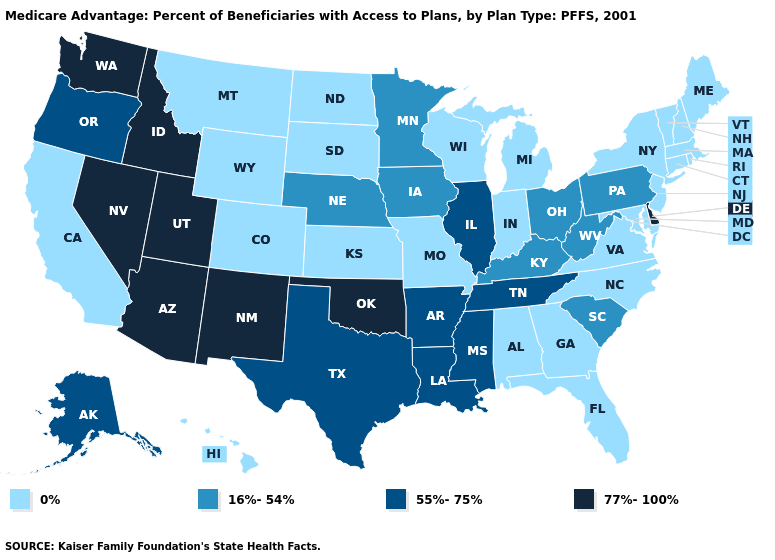Does Pennsylvania have the lowest value in the Northeast?
Answer briefly. No. Name the states that have a value in the range 55%-75%?
Give a very brief answer. Alaska, Arkansas, Illinois, Louisiana, Mississippi, Oregon, Tennessee, Texas. What is the value of Iowa?
Give a very brief answer. 16%-54%. What is the value of Pennsylvania?
Write a very short answer. 16%-54%. Does Nevada have a lower value than Massachusetts?
Concise answer only. No. Name the states that have a value in the range 0%?
Write a very short answer. Alabama, California, Colorado, Connecticut, Florida, Georgia, Hawaii, Indiana, Kansas, Massachusetts, Maryland, Maine, Michigan, Missouri, Montana, North Carolina, North Dakota, New Hampshire, New Jersey, New York, Rhode Island, South Dakota, Virginia, Vermont, Wisconsin, Wyoming. What is the value of Texas?
Be succinct. 55%-75%. Does Idaho have the highest value in the West?
Concise answer only. Yes. What is the value of New York?
Short answer required. 0%. Name the states that have a value in the range 0%?
Short answer required. Alabama, California, Colorado, Connecticut, Florida, Georgia, Hawaii, Indiana, Kansas, Massachusetts, Maryland, Maine, Michigan, Missouri, Montana, North Carolina, North Dakota, New Hampshire, New Jersey, New York, Rhode Island, South Dakota, Virginia, Vermont, Wisconsin, Wyoming. What is the value of Montana?
Short answer required. 0%. What is the value of Nevada?
Give a very brief answer. 77%-100%. Which states hav the highest value in the West?
Quick response, please. Arizona, Idaho, New Mexico, Nevada, Utah, Washington. What is the highest value in the South ?
Answer briefly. 77%-100%. Does Idaho have the highest value in the USA?
Keep it brief. Yes. 